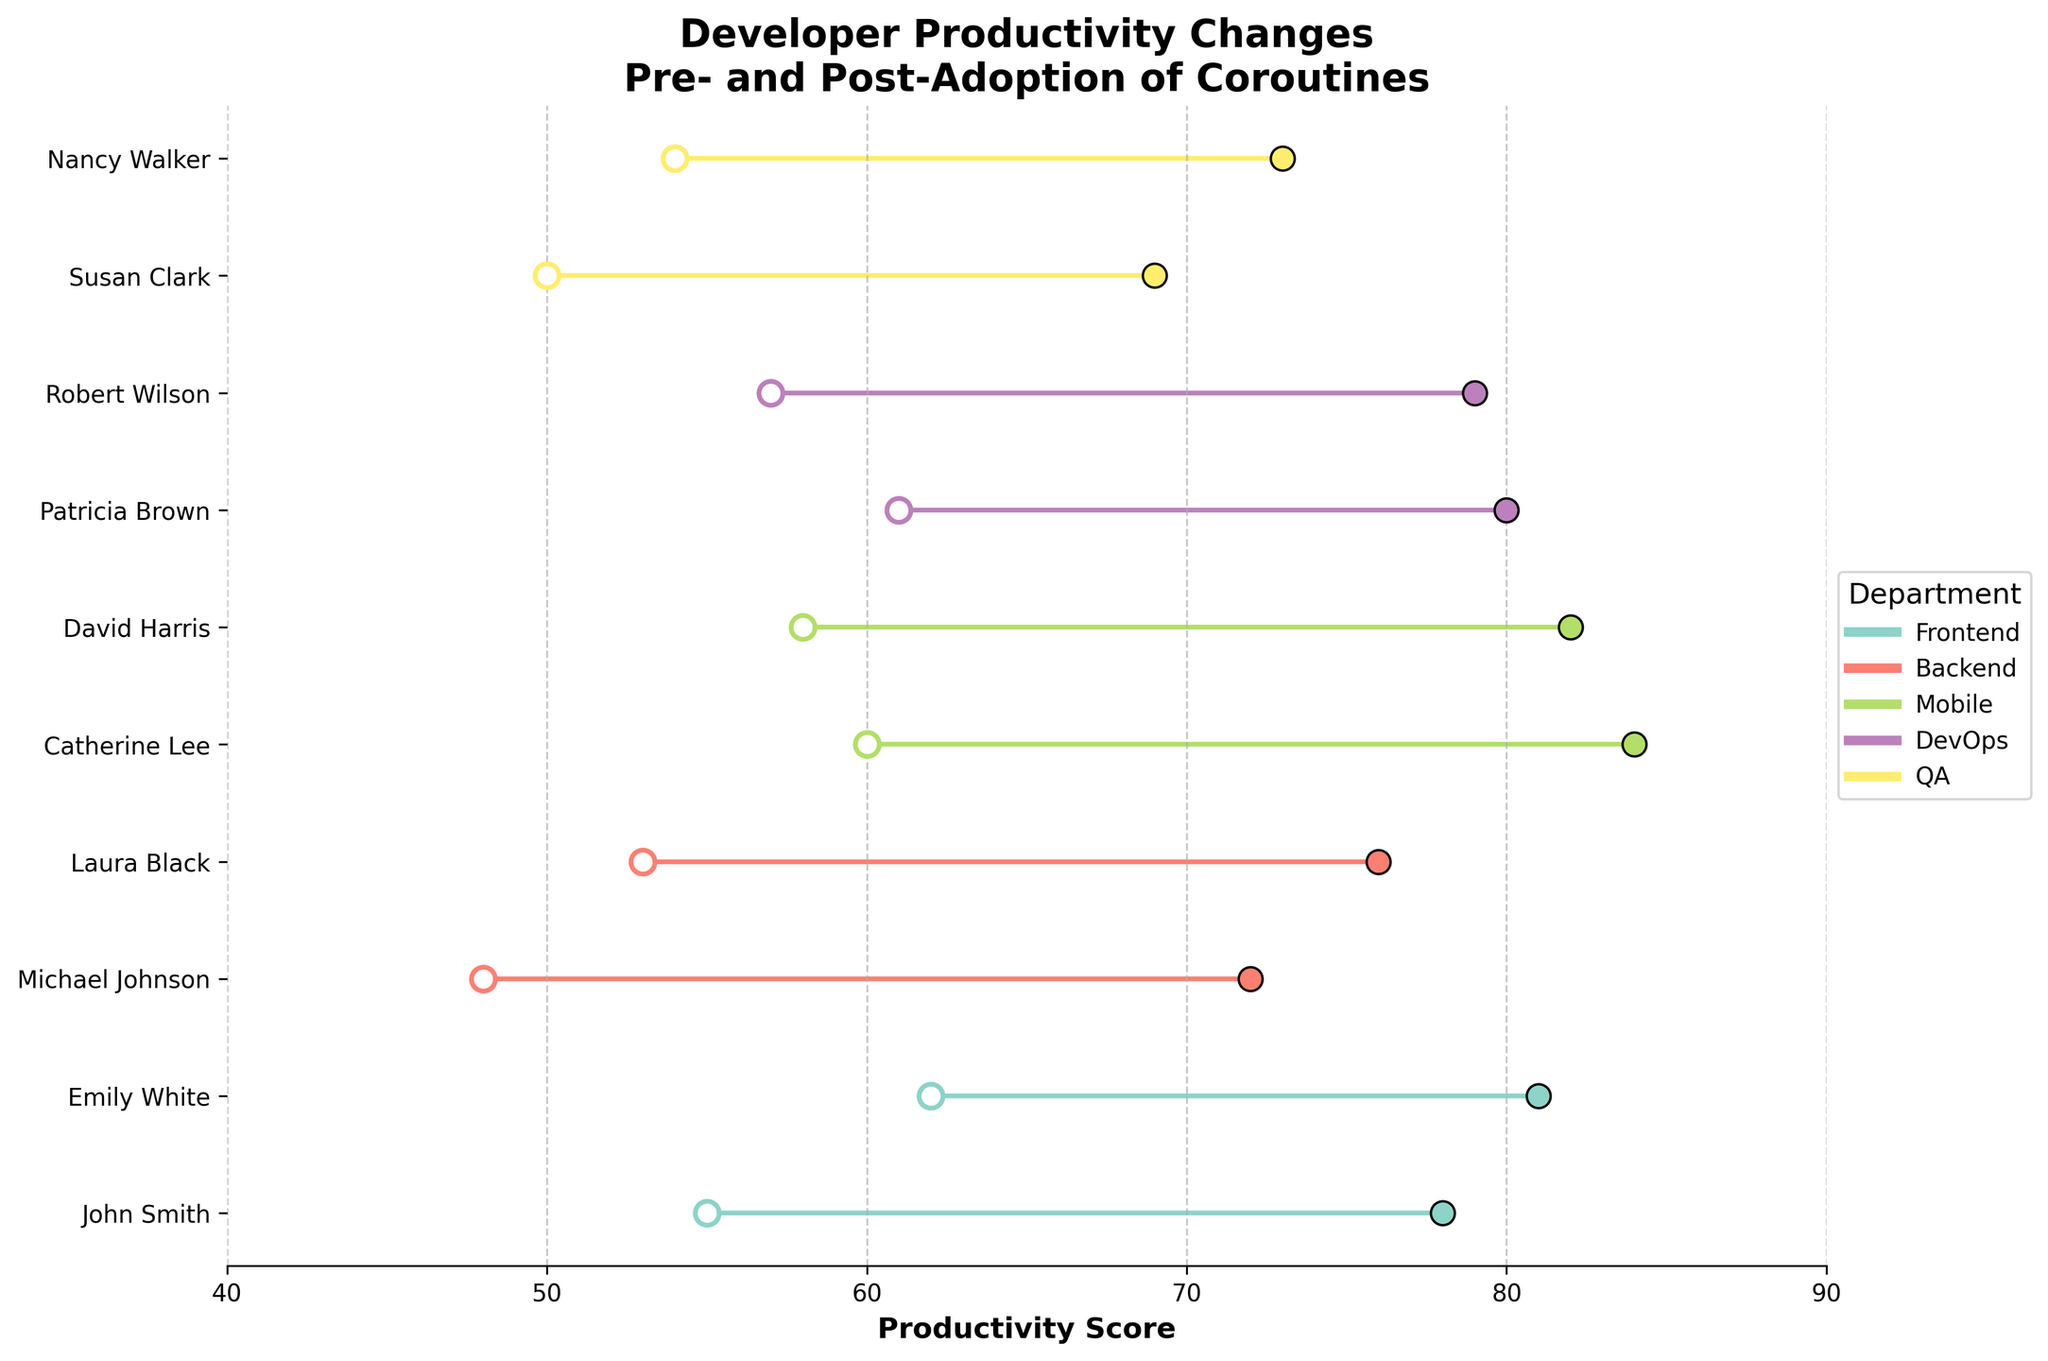what is the title of the figure? The title is found at the top of the figure in a bold font. It provides the main subject of the plot.
Answer: Developer Productivity Changes Pre- and Post-Adoption of Coroutines how many departments are represented in the figure? You can count the unique departments listed in the legend to determine the number of departments.
Answer: 5 which developer has the largest increase in productivity after the adoption of coroutines? Look for the developer with the largest difference between the pre-adoption and post-adoption productivity scores on the x-axis.
Answer: Catherine Lee what is the average productivity score pre-adoption for backend developers? Add up the pre-adoption productivity scores for all backend developers and divide by the number of backend developers. (48 + 53) / 2 = 50.5
Answer: 50.5 which department shows the smallest increase in productivity post-adoption? Compare the pre- and post-adoption productivity scores for each department. Find the department with the smallest total increase. Frontend: John Smith (23), Emily White (19); Backend: Michael Johnson (24), Laura Black (23); Mobile: Catherine Lee (24), David Harris (24); DevOps: Patricia Brown (19), Robert Wilson (22); QA: Susan Clark (19), Nancy Walker (19). The smallest total increase is in the QA department.
Answer: QA which developer in the frontend department had a higher productivity score pre-adoption? Compare the pre-adoption productivity scores of the developers in the frontend department listed in the y-tick labels to find the one with the higher score.
Answer: Emily White what was the productivity score for Susan Clark post-adoption of coroutines? Locate Susan Clark along the y-axis, then find her post-adoption productivity score along the x-axis.
Answer: 69 how did the productivity of DevOps developers change on average after coroutines adoption? Calculate the difference in productivity scores for each DevOps developer and then find the average increment. (Patricia Brown: 19, Robert Wilson: 22, (19+22)/2 = 20.5)
Answer: 20.5 